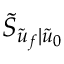Convert formula to latex. <formula><loc_0><loc_0><loc_500><loc_500>\tilde { S } _ { \tilde { u } _ { f } | \tilde { u } _ { 0 } }</formula> 